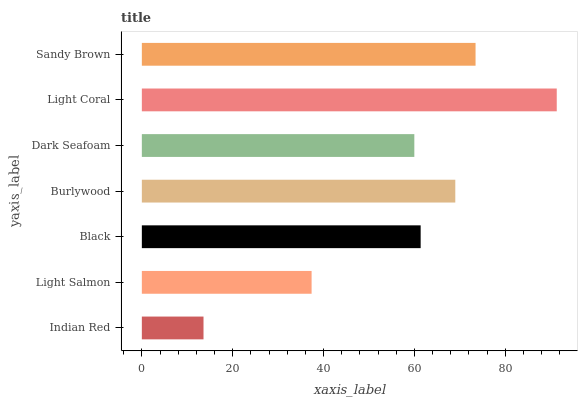Is Indian Red the minimum?
Answer yes or no. Yes. Is Light Coral the maximum?
Answer yes or no. Yes. Is Light Salmon the minimum?
Answer yes or no. No. Is Light Salmon the maximum?
Answer yes or no. No. Is Light Salmon greater than Indian Red?
Answer yes or no. Yes. Is Indian Red less than Light Salmon?
Answer yes or no. Yes. Is Indian Red greater than Light Salmon?
Answer yes or no. No. Is Light Salmon less than Indian Red?
Answer yes or no. No. Is Black the high median?
Answer yes or no. Yes. Is Black the low median?
Answer yes or no. Yes. Is Dark Seafoam the high median?
Answer yes or no. No. Is Light Coral the low median?
Answer yes or no. No. 